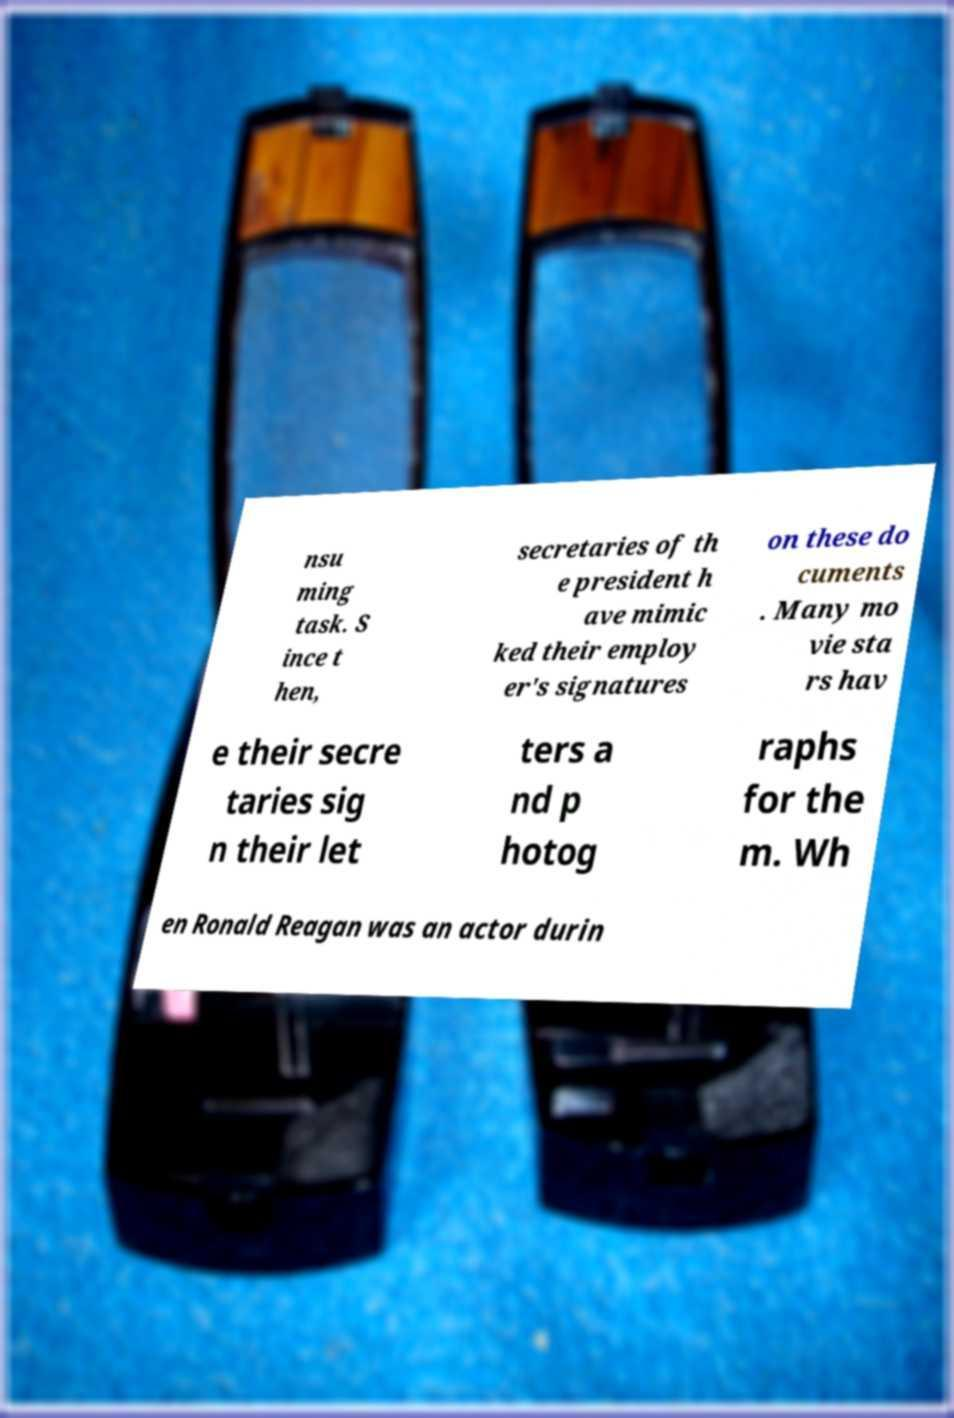Could you extract and type out the text from this image? nsu ming task. S ince t hen, secretaries of th e president h ave mimic ked their employ er's signatures on these do cuments . Many mo vie sta rs hav e their secre taries sig n their let ters a nd p hotog raphs for the m. Wh en Ronald Reagan was an actor durin 